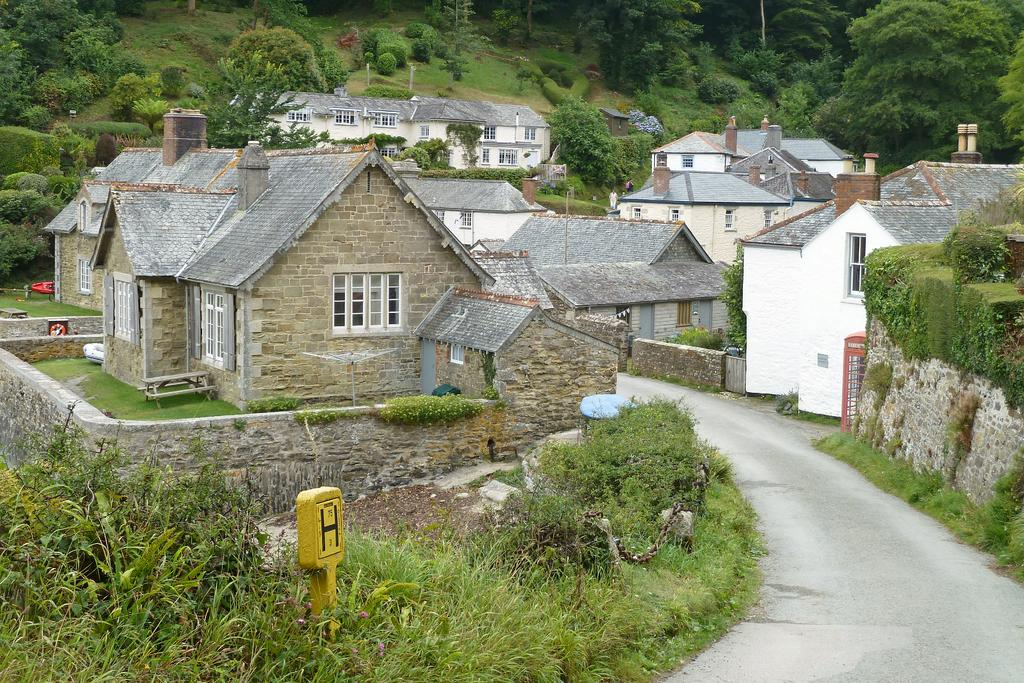What is the main feature of the image? There is a road in the image. What can be seen on either side of the road? There are houses with chimneys on either side of the road. What is visible in the background of the image? Greenery, plants, and trees are visible in the background. Can you tell me how many times the dad and the boy appear in the image? There is no dad or boy present in the image; it features a road, houses, and greenery in the background. 